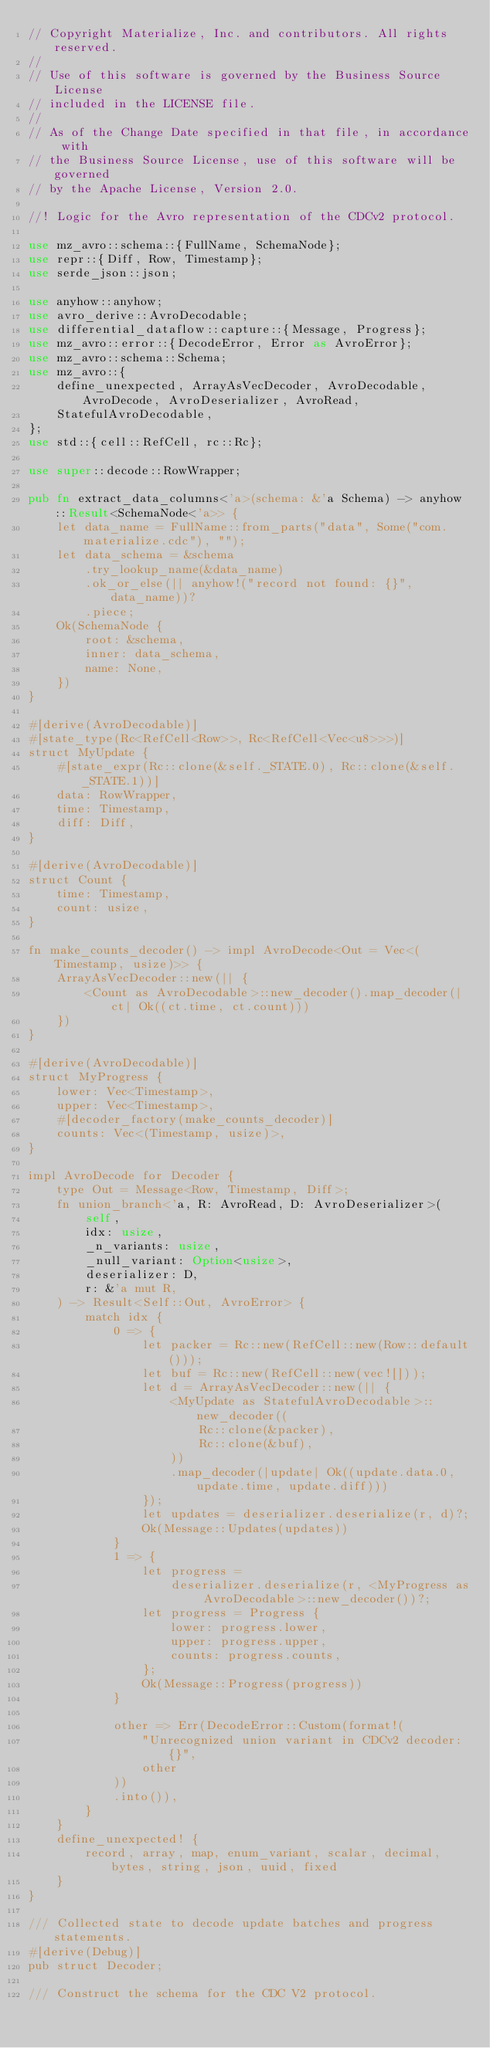<code> <loc_0><loc_0><loc_500><loc_500><_Rust_>// Copyright Materialize, Inc. and contributors. All rights reserved.
//
// Use of this software is governed by the Business Source License
// included in the LICENSE file.
//
// As of the Change Date specified in that file, in accordance with
// the Business Source License, use of this software will be governed
// by the Apache License, Version 2.0.

//! Logic for the Avro representation of the CDCv2 protocol.

use mz_avro::schema::{FullName, SchemaNode};
use repr::{Diff, Row, Timestamp};
use serde_json::json;

use anyhow::anyhow;
use avro_derive::AvroDecodable;
use differential_dataflow::capture::{Message, Progress};
use mz_avro::error::{DecodeError, Error as AvroError};
use mz_avro::schema::Schema;
use mz_avro::{
    define_unexpected, ArrayAsVecDecoder, AvroDecodable, AvroDecode, AvroDeserializer, AvroRead,
    StatefulAvroDecodable,
};
use std::{cell::RefCell, rc::Rc};

use super::decode::RowWrapper;

pub fn extract_data_columns<'a>(schema: &'a Schema) -> anyhow::Result<SchemaNode<'a>> {
    let data_name = FullName::from_parts("data", Some("com.materialize.cdc"), "");
    let data_schema = &schema
        .try_lookup_name(&data_name)
        .ok_or_else(|| anyhow!("record not found: {}", data_name))?
        .piece;
    Ok(SchemaNode {
        root: &schema,
        inner: data_schema,
        name: None,
    })
}

#[derive(AvroDecodable)]
#[state_type(Rc<RefCell<Row>>, Rc<RefCell<Vec<u8>>>)]
struct MyUpdate {
    #[state_expr(Rc::clone(&self._STATE.0), Rc::clone(&self._STATE.1))]
    data: RowWrapper,
    time: Timestamp,
    diff: Diff,
}

#[derive(AvroDecodable)]
struct Count {
    time: Timestamp,
    count: usize,
}

fn make_counts_decoder() -> impl AvroDecode<Out = Vec<(Timestamp, usize)>> {
    ArrayAsVecDecoder::new(|| {
        <Count as AvroDecodable>::new_decoder().map_decoder(|ct| Ok((ct.time, ct.count)))
    })
}

#[derive(AvroDecodable)]
struct MyProgress {
    lower: Vec<Timestamp>,
    upper: Vec<Timestamp>,
    #[decoder_factory(make_counts_decoder)]
    counts: Vec<(Timestamp, usize)>,
}

impl AvroDecode for Decoder {
    type Out = Message<Row, Timestamp, Diff>;
    fn union_branch<'a, R: AvroRead, D: AvroDeserializer>(
        self,
        idx: usize,
        _n_variants: usize,
        _null_variant: Option<usize>,
        deserializer: D,
        r: &'a mut R,
    ) -> Result<Self::Out, AvroError> {
        match idx {
            0 => {
                let packer = Rc::new(RefCell::new(Row::default()));
                let buf = Rc::new(RefCell::new(vec![]));
                let d = ArrayAsVecDecoder::new(|| {
                    <MyUpdate as StatefulAvroDecodable>::new_decoder((
                        Rc::clone(&packer),
                        Rc::clone(&buf),
                    ))
                    .map_decoder(|update| Ok((update.data.0, update.time, update.diff)))
                });
                let updates = deserializer.deserialize(r, d)?;
                Ok(Message::Updates(updates))
            }
            1 => {
                let progress =
                    deserializer.deserialize(r, <MyProgress as AvroDecodable>::new_decoder())?;
                let progress = Progress {
                    lower: progress.lower,
                    upper: progress.upper,
                    counts: progress.counts,
                };
                Ok(Message::Progress(progress))
            }

            other => Err(DecodeError::Custom(format!(
                "Unrecognized union variant in CDCv2 decoder: {}",
                other
            ))
            .into()),
        }
    }
    define_unexpected! {
        record, array, map, enum_variant, scalar, decimal, bytes, string, json, uuid, fixed
    }
}

/// Collected state to decode update batches and progress statements.
#[derive(Debug)]
pub struct Decoder;

/// Construct the schema for the CDC V2 protocol.</code> 